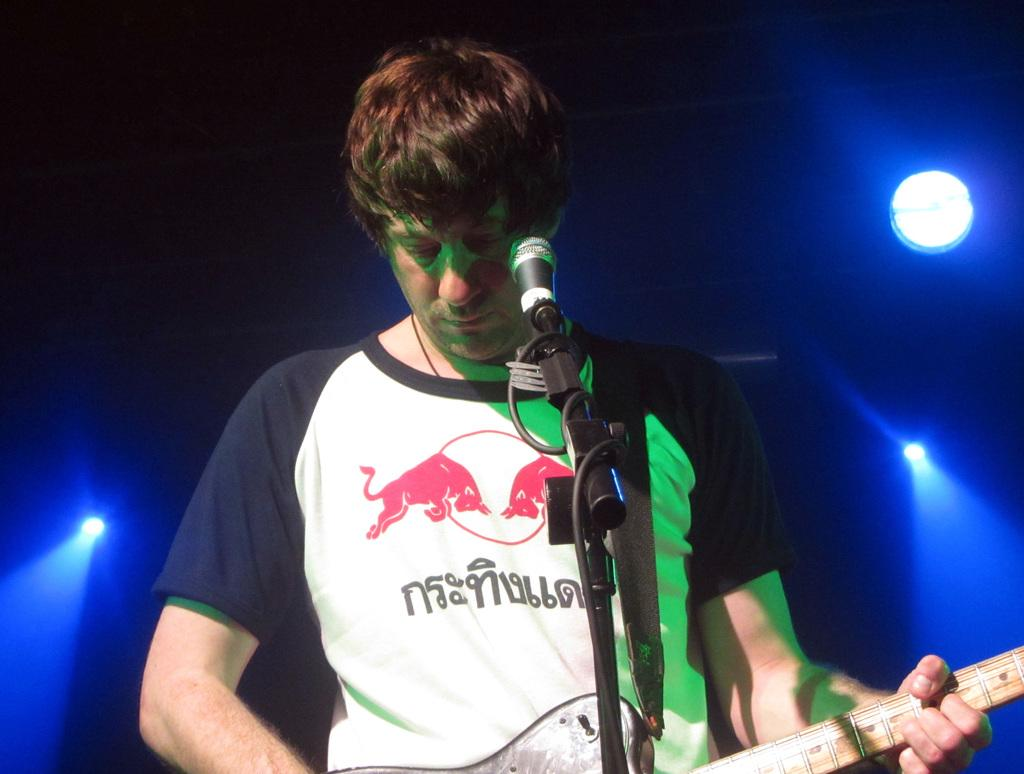Who is the main subject in the image? There is a man in the image. What is the man wearing? The man is wearing a t-shirt. What activity is the man engaged in? The man is playing a guitar. What object is in front of the man? There is a microphone in front of the man. What type of lighting can be seen in the image? There are focusing lights visible in the image. How many toes can be seen on the man's head in the image? There are no toes visible on the man's head in the image, as the man is not depicted with any toes on his head. 